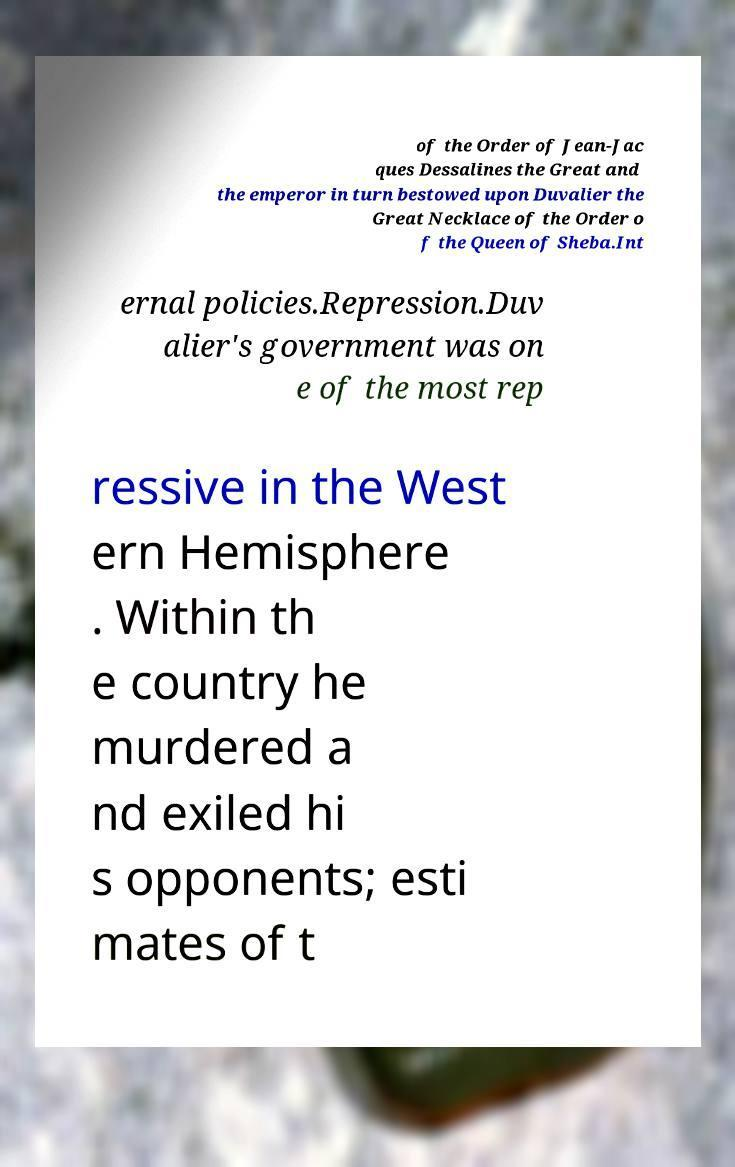Could you extract and type out the text from this image? of the Order of Jean-Jac ques Dessalines the Great and the emperor in turn bestowed upon Duvalier the Great Necklace of the Order o f the Queen of Sheba.Int ernal policies.Repression.Duv alier's government was on e of the most rep ressive in the West ern Hemisphere . Within th e country he murdered a nd exiled hi s opponents; esti mates of t 